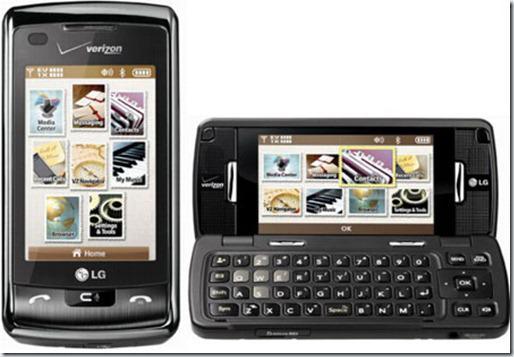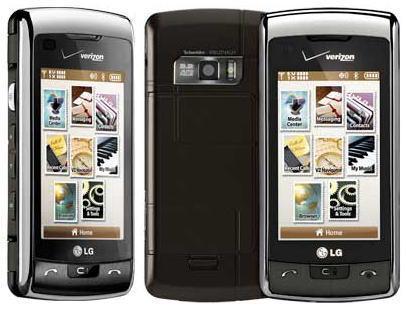The first image is the image on the left, the second image is the image on the right. Assess this claim about the two images: "The left and right image contains the same number of vertical phones.". Correct or not? Answer yes or no. No. The first image is the image on the left, the second image is the image on the right. Considering the images on both sides, is "Each image contains exactly three phones, which are displayed vertically facing screen-first and do not have a flip-open top." valid? Answer yes or no. No. 